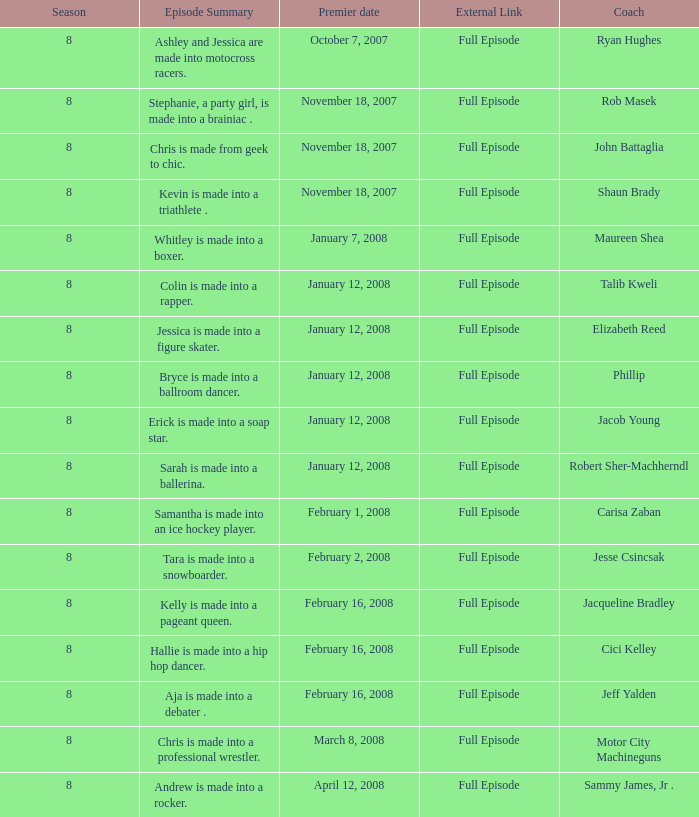What was Cici Kelley's minimum season? 8.0. Can you parse all the data within this table? {'header': ['Season', 'Episode Summary', 'Premier date', 'External Link', 'Coach'], 'rows': [['8', 'Ashley and Jessica are made into motocross racers.', 'October 7, 2007', 'Full Episode', 'Ryan Hughes'], ['8', 'Stephanie, a party girl, is made into a brainiac .', 'November 18, 2007', 'Full Episode', 'Rob Masek'], ['8', 'Chris is made from geek to chic.', 'November 18, 2007', 'Full Episode', 'John Battaglia'], ['8', 'Kevin is made into a triathlete .', 'November 18, 2007', 'Full Episode', 'Shaun Brady'], ['8', 'Whitley is made into a boxer.', 'January 7, 2008', 'Full Episode', 'Maureen Shea'], ['8', 'Colin is made into a rapper.', 'January 12, 2008', 'Full Episode', 'Talib Kweli'], ['8', 'Jessica is made into a figure skater.', 'January 12, 2008', 'Full Episode', 'Elizabeth Reed'], ['8', 'Bryce is made into a ballroom dancer.', 'January 12, 2008', 'Full Episode', 'Phillip'], ['8', 'Erick is made into a soap star.', 'January 12, 2008', 'Full Episode', 'Jacob Young'], ['8', 'Sarah is made into a ballerina.', 'January 12, 2008', 'Full Episode', 'Robert Sher-Machherndl'], ['8', 'Samantha is made into an ice hockey player.', 'February 1, 2008', 'Full Episode', 'Carisa Zaban'], ['8', 'Tara is made into a snowboarder.', 'February 2, 2008', 'Full Episode', 'Jesse Csincsak'], ['8', 'Kelly is made into a pageant queen.', 'February 16, 2008', 'Full Episode', 'Jacqueline Bradley'], ['8', 'Hallie is made into a hip hop dancer.', 'February 16, 2008', 'Full Episode', 'Cici Kelley'], ['8', 'Aja is made into a debater .', 'February 16, 2008', 'Full Episode', 'Jeff Yalden'], ['8', 'Chris is made into a professional wrestler.', 'March 8, 2008', 'Full Episode', 'Motor City Machineguns'], ['8', 'Andrew is made into a rocker.', 'April 12, 2008', 'Full Episode', 'Sammy James, Jr .']]} 